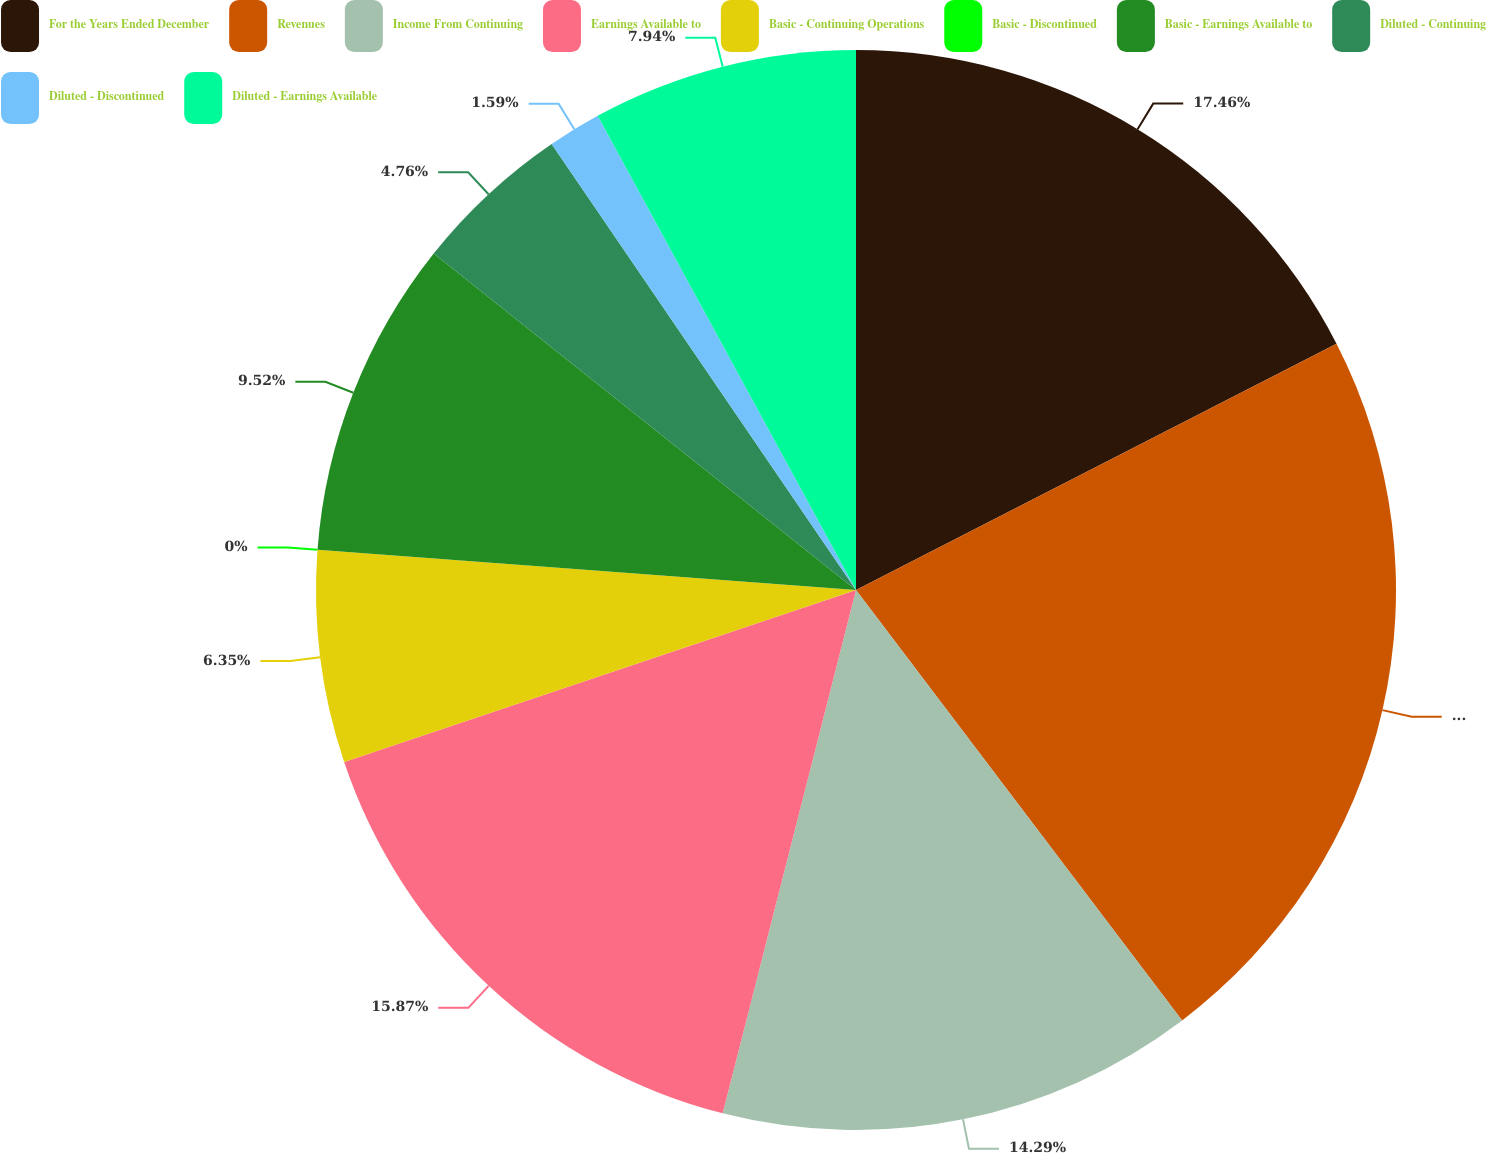Convert chart to OTSL. <chart><loc_0><loc_0><loc_500><loc_500><pie_chart><fcel>For the Years Ended December<fcel>Revenues<fcel>Income From Continuing<fcel>Earnings Available to<fcel>Basic - Continuing Operations<fcel>Basic - Discontinued<fcel>Basic - Earnings Available to<fcel>Diluted - Continuing<fcel>Diluted - Discontinued<fcel>Diluted - Earnings Available<nl><fcel>17.46%<fcel>22.22%<fcel>14.29%<fcel>15.87%<fcel>6.35%<fcel>0.0%<fcel>9.52%<fcel>4.76%<fcel>1.59%<fcel>7.94%<nl></chart> 